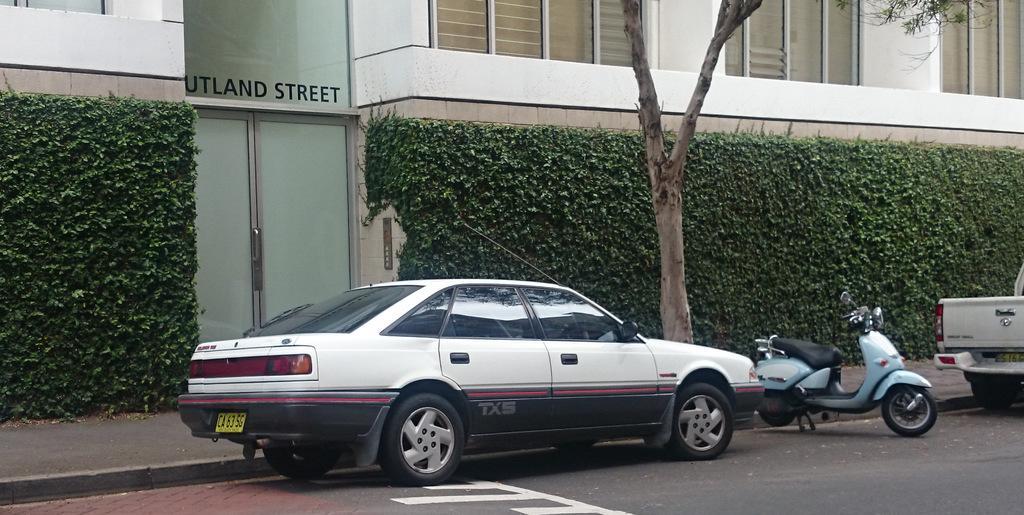Please provide a concise description of this image. In the center of the image we can see cars and a bike on the road. In the background there is a building and we can see a hedge and a tree. There is a door and windows. 